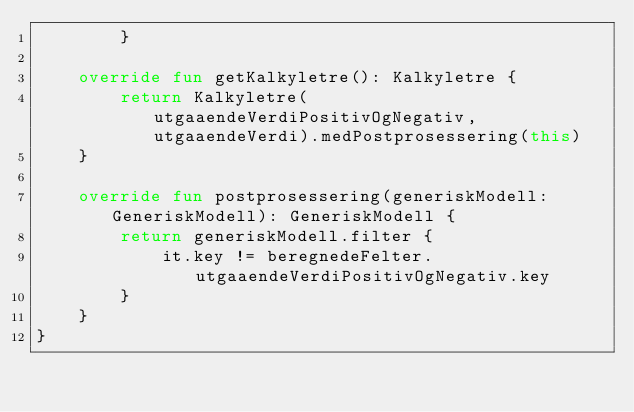Convert code to text. <code><loc_0><loc_0><loc_500><loc_500><_Kotlin_>        }

    override fun getKalkyletre(): Kalkyletre {
        return Kalkyletre(utgaaendeVerdiPositivOgNegativ, utgaaendeVerdi).medPostprosessering(this)
    }

    override fun postprosessering(generiskModell: GeneriskModell): GeneriskModell {
        return generiskModell.filter {
            it.key != beregnedeFelter.utgaaendeVerdiPositivOgNegativ.key
        }
    }
}</code> 